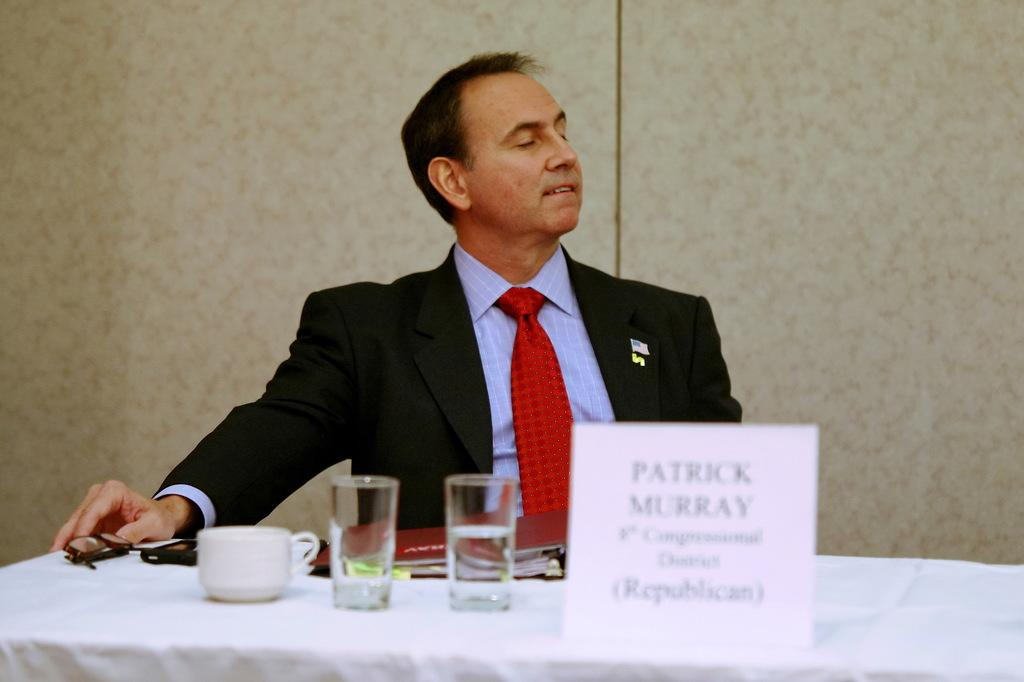What is the man in the image doing? The man is sitting on a chair in the image. What is in front of the man? There is a table in front of the man. What can be seen on the table? There is a cup, glasses, and a name card on the table. What type of coat is the man wearing in the image? The man is not wearing a coat in the image. How many dinosaurs are visible in the image? There are no dinosaurs present in the image. 